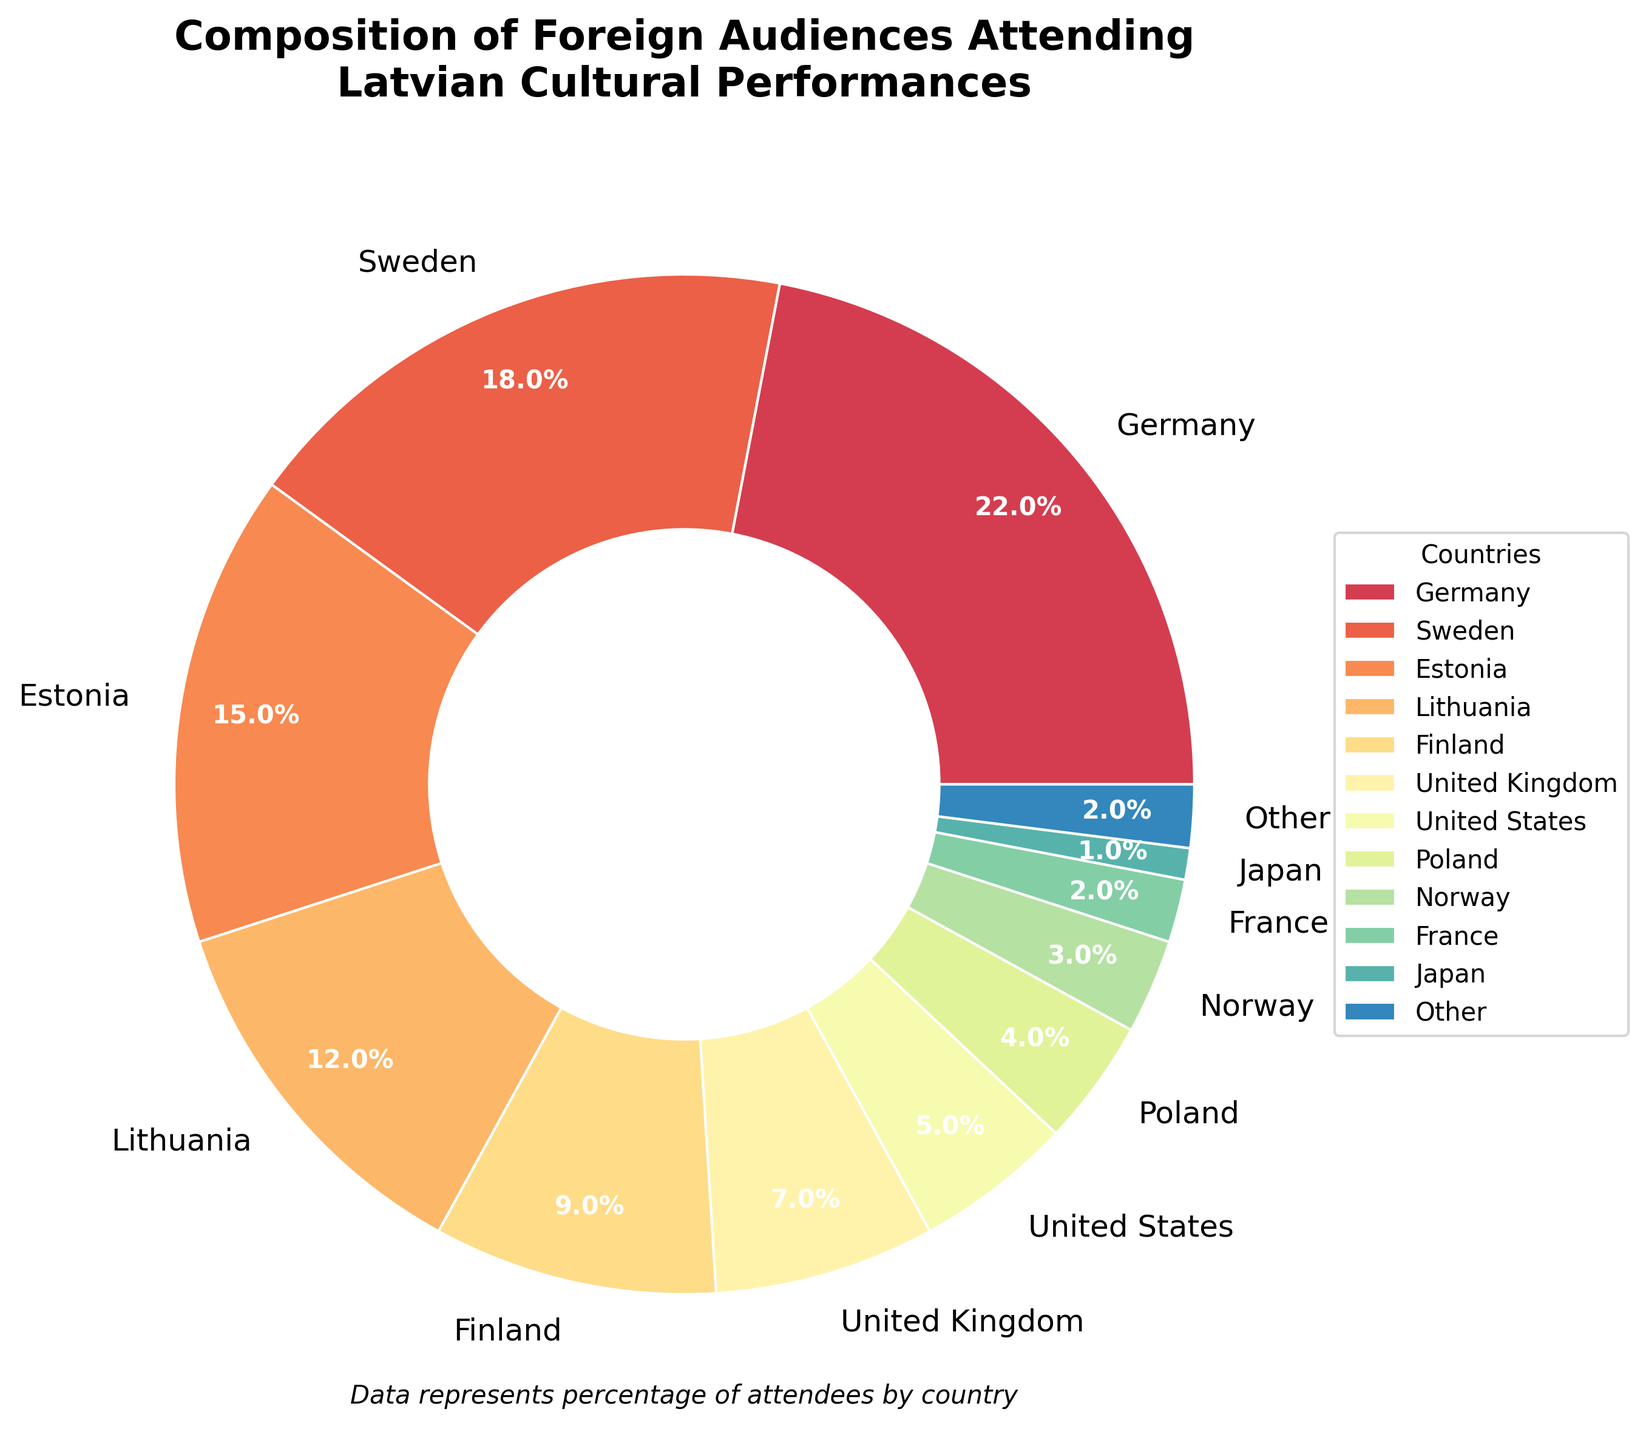What is the percentage difference between audiences from Germany and the United Kingdom? First, note the percentage of audiences from Germany (22%) and the United Kingdom (7%). Then, calculate the difference: 22% - 7% = 15%.
Answer: 15% Which country has a higher proportion of attendees, Sweden or Finland? Check the percentages for Sweden (18%) and Finland (9%). Since 18% is greater than 9%, Sweden has a higher proportion.
Answer: Sweden What is the total percentage of audiences from Germany, Sweden, and Estonia combined? Add the percentages from Germany (22%), Sweden (18%), and Estonia (15%): 22% + 18% + 15% = 55%.
Answer: 55% How many countries have less than 5% of the audience share? Identify the countries with less than 5%: United States (5%), Poland (4%), Norway (3%), France (2%), Japan (1%), Other (2%). The count is 5 (Poland, Norway, France, Japan, Other).
Answer: 5 What is the percentage of the audience from Lithuania compared to the percentage from Finland? Check the percentages: Lithuania (12%), Finland (9%). Lithuania has a higher percentage.
Answer: Lithuania What is the combined percentage of audiences from the United Kingdom, the United States, and Other? Sum the percentages for the United Kingdom (7%), the United States (5%), and Other (2%): 7% + 5% + 2% = 14%.
Answer: 14% Which country has the smallest share of audiences? Analyze the percentages and identify that Japan has the smallest share at 1%.
Answer: Japan What is the average percentage of audiences from the top three countries? The top three countries are Germany (22%), Sweden (18%), and Estonia (15%). Calculate the average: (22% + 18% + 15%) / 3 = 18.33%.
Answer: 18.33% What is the difference in percentage between audiences from the least and most popular countries? Note that Japan has the least share (1%) and Germany the most (22%). Calculate the difference: 22% - 1% = 21%.
Answer: 21% 